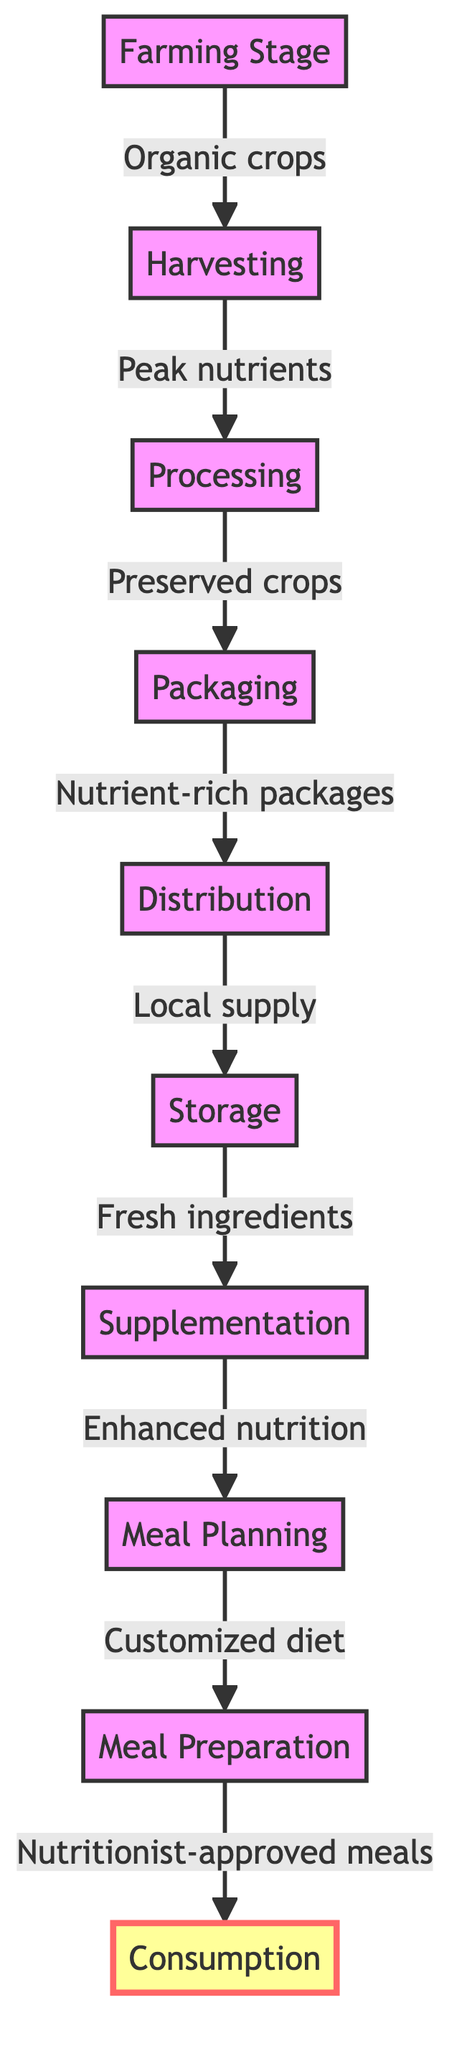What is the first step in the nutritional journey? The first step indicated in the diagram is "Farming Stage," where organic crops are grown.
Answer: Farming Stage How many stages are shown in the diagram? By counting the nodes from "Farming Stage" to "Consumption," there are a total of ten stages depicted in the flowchart.
Answer: Ten What follows the harvesting stage? The diagram shows that "Processing" directly follows "Harvesting."
Answer: Processing What type of packages are produced during the packaging stage? According to the flowchart, packages produced during this stage are labeled as "Nutrient-rich packages."
Answer: Nutrient-rich packages What enhances nutrition before meal planning? The stage labeled "Supplementation" enhances nutrition before the meal planning process.
Answer: Supplementation What is the relationship between packaging and distribution? The flowchart indicates that "Packaging" leads to "Distribution," representing a direct connection where packaged products are distributed.
Answer: Direct connection How does meal preparation relate to nutritionist approval? "Meal Preparation" is directly linked to "Nutritionist-approved meals," indicating that meals are prepared after they have been approved by a nutritionist.
Answer: Prepared after approval What is the last step in the nutritional journey? The final step in the journey, as depicted in the flowchart, is "Consumption," where the meals are consumed by the boxer.
Answer: Consumption What is received at the storage stage? The storage stage receives "Fresh ingredients," which are essential for later stages of meal preparation and consumption.
Answer: Fresh ingredients How does distribution affect storage? "Distribution," which provides local supply, directly impacts "Storage," ensuring that fresh ingredients are readily available.
Answer: Ensures fresh ingredients are available 